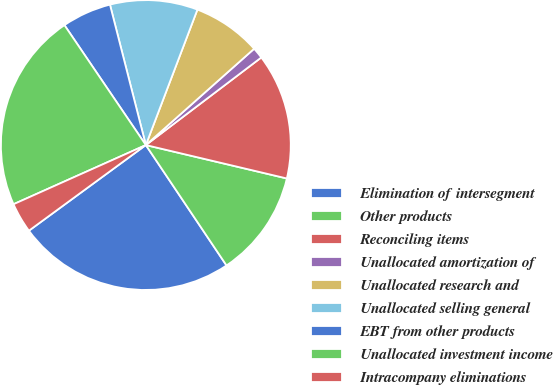Convert chart to OTSL. <chart><loc_0><loc_0><loc_500><loc_500><pie_chart><fcel>Elimination of intersegment<fcel>Other products<fcel>Reconciling items<fcel>Unallocated amortization of<fcel>Unallocated research and<fcel>Unallocated selling general<fcel>EBT from other products<fcel>Unallocated investment income<fcel>Intracompany eliminations<nl><fcel>24.33%<fcel>11.9%<fcel>14.03%<fcel>1.24%<fcel>7.64%<fcel>9.77%<fcel>5.51%<fcel>22.2%<fcel>3.37%<nl></chart> 